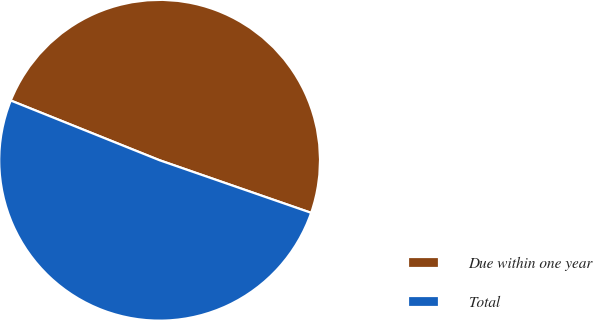Convert chart to OTSL. <chart><loc_0><loc_0><loc_500><loc_500><pie_chart><fcel>Due within one year<fcel>Total<nl><fcel>49.24%<fcel>50.76%<nl></chart> 